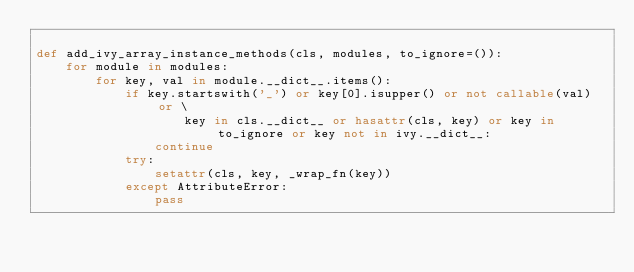Convert code to text. <code><loc_0><loc_0><loc_500><loc_500><_Python_>
def add_ivy_array_instance_methods(cls, modules, to_ignore=()):
    for module in modules:
        for key, val in module.__dict__.items():
            if key.startswith('_') or key[0].isupper() or not callable(val) or \
                    key in cls.__dict__ or hasattr(cls, key) or key in to_ignore or key not in ivy.__dict__:
                continue
            try:
                setattr(cls, key, _wrap_fn(key))
            except AttributeError:
                pass
</code> 